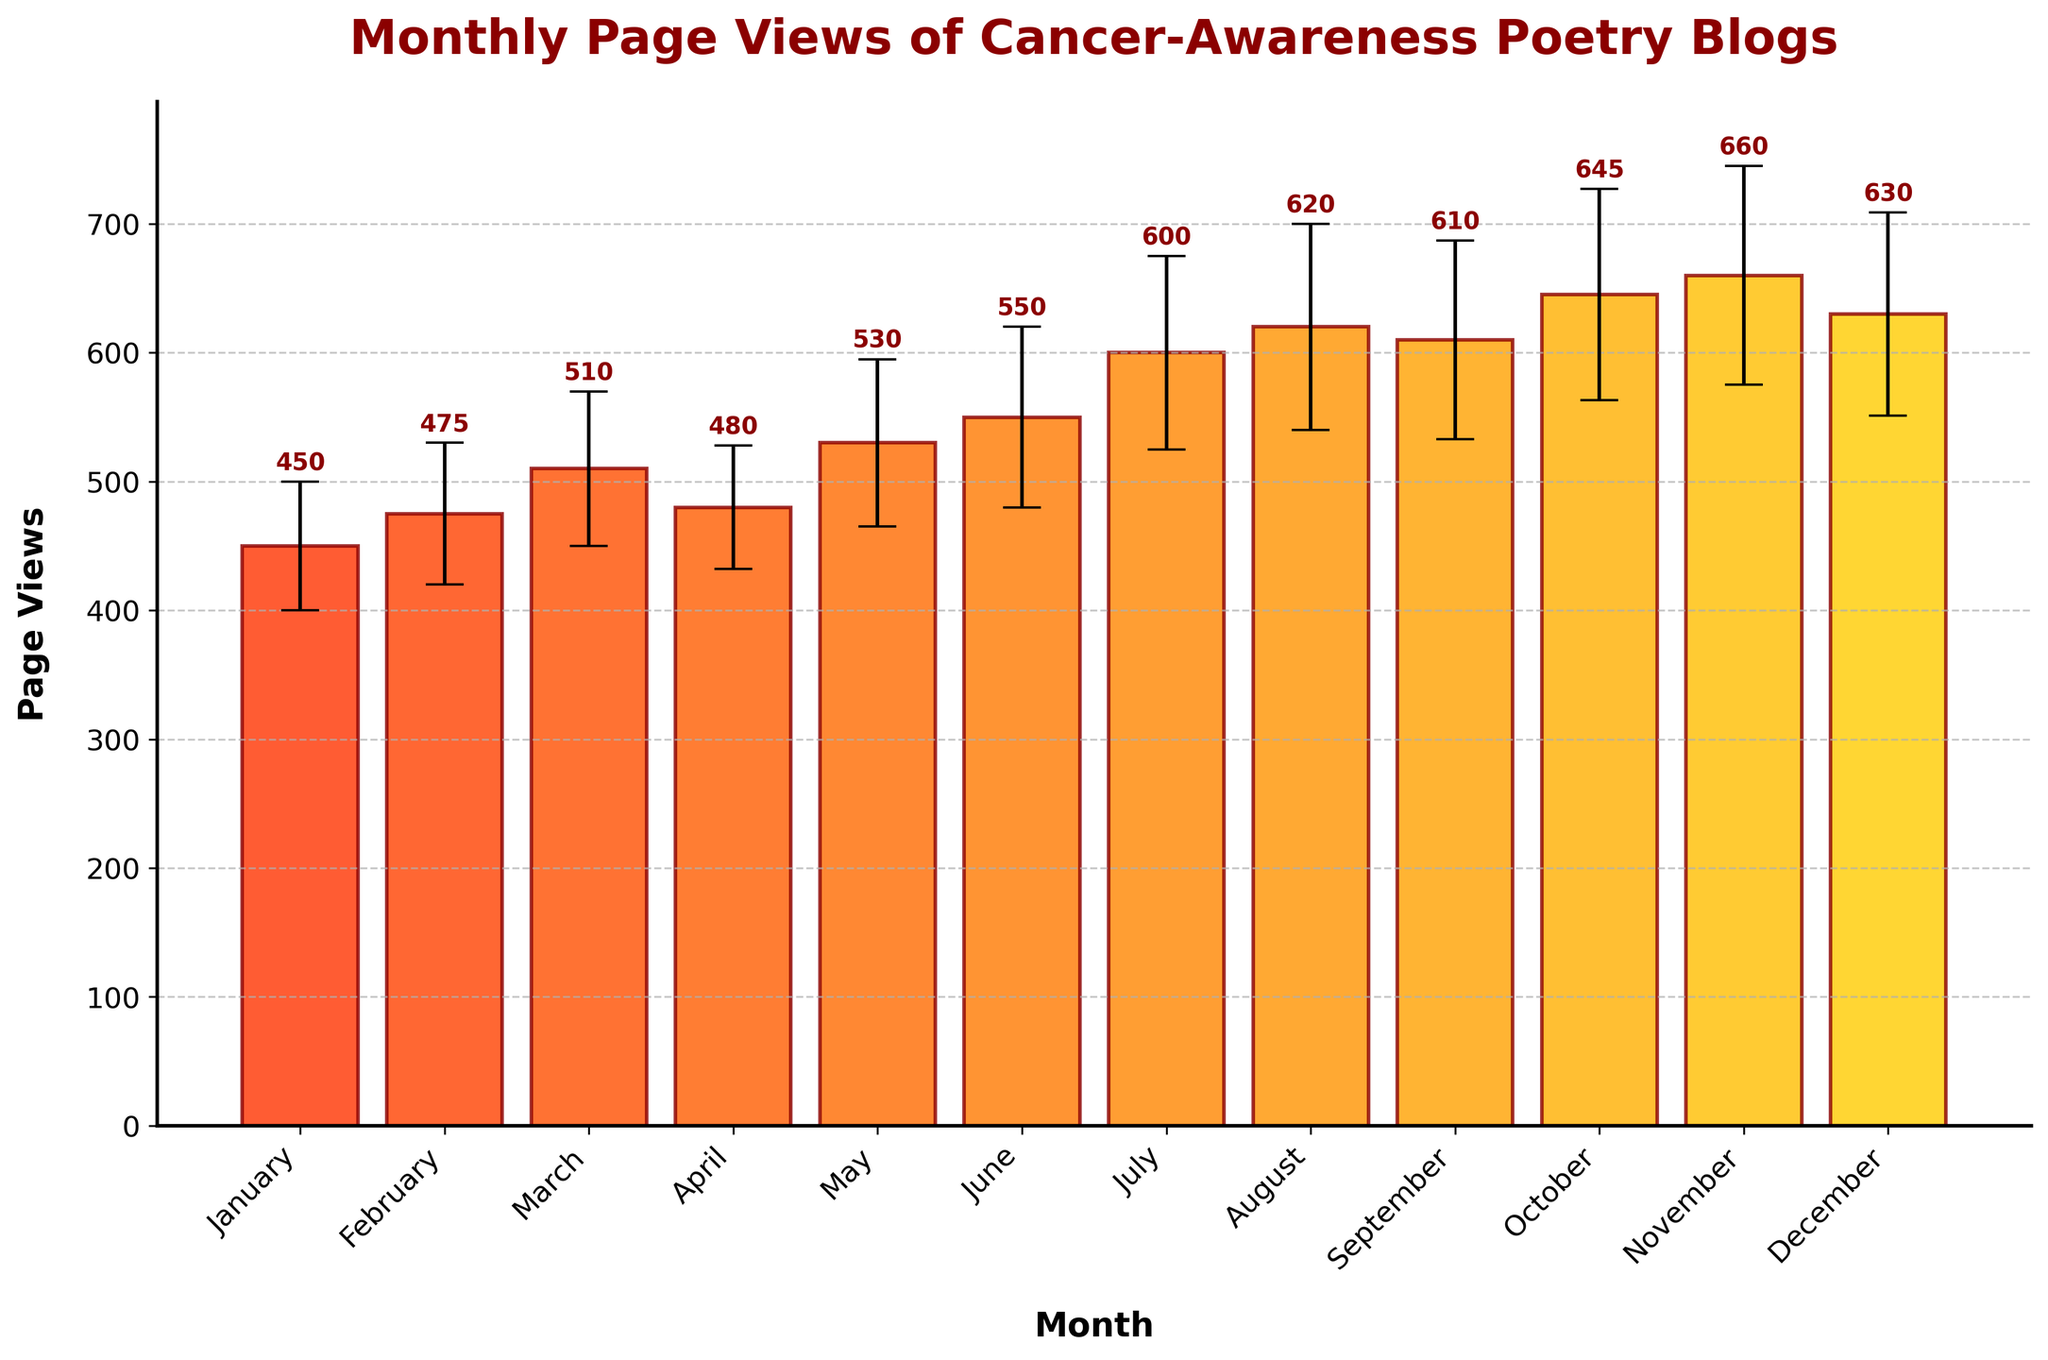What is the title of the bar chart? The title appears at the top of the chart, indicating the chart's focus.
Answer: Monthly Page Views of Cancer-Awareness Poetry Blogs Which month had the highest number of page views? By visually inspecting the heights of the bars, the month with the tallest bar has the highest page views.
Answer: November What is the range of the y-axis? The y-axis range is from the minimum to the maximum value indicated by the axis ticks.
Answer: 0 to 750 Which month had the lowest number of page views? By looking at the bar heights, the shortest bar indicates the month with the lowest page views.
Answer: January What is the page view count for July? The text label above the bar for July shows the count, along with the height of the bar.
Answer: 600 What is the average number of page views from July to December? Sum the page views for July to December and divide by the number of months: (600 + 620 + 610 + 645 + 660 + 630) / 6 = 3765 / 6.
Answer: 627.5 How does the page view count in August compare to January? August has more page views than January as indicated by comparing the heights of their respective bars.
Answer: August has higher page views than January Which month had the largest standard deviation in page views? The length of the error bars indicates the standard deviation; the longest error bar corresponds to the largest standard deviation.
Answer: November What is the difference in page views between October and November? Subtract the page view count for October from that of November: 660 - 645.
Answer: 15 Are the page views in September higher than those in March? Compare the heights of the bars for September and March.
Answer: Yes, September has higher page views than March 